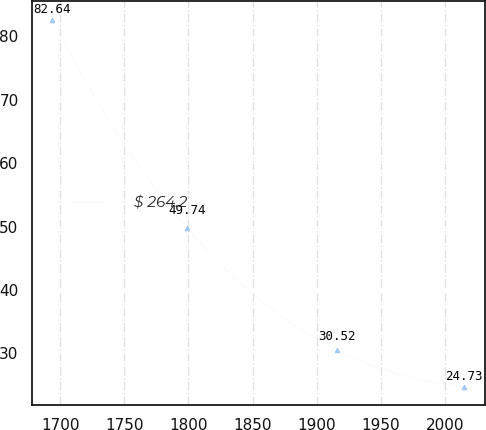Convert chart to OTSL. <chart><loc_0><loc_0><loc_500><loc_500><line_chart><ecel><fcel>$ 264.2<nl><fcel>1693.92<fcel>82.64<nl><fcel>1799.09<fcel>49.74<nl><fcel>1915.83<fcel>30.52<nl><fcel>2014.85<fcel>24.73<nl></chart> 